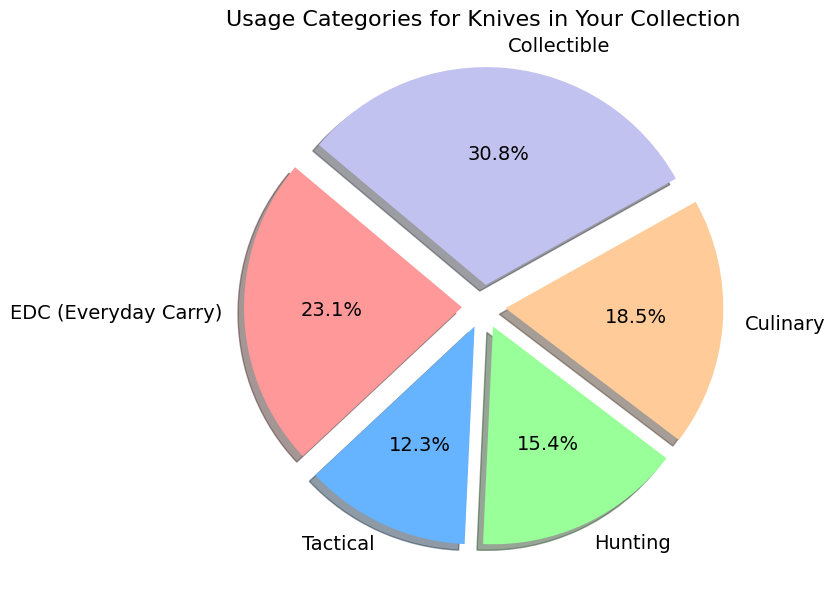What is the most common usage category for knives in your collection? The pie chart shows the proportions of different knife usage categories. The largest section of the pie chart, labeled with the highest percentage, represents the most common category.
Answer: Collectible What percentage of your knife collection is used for Culinary purposes? The percentage for each category is directly labeled on the pie chart. Look for the segment labeled "Culinary".
Answer: 24.0% Which category has more knives: Tactical or Hunting? Compare the respective sections of the pie chart labeled "Tactical" and "Hunting". The size and percentage indicate the quantity, with a higher percentage indicating more knives.
Answer: Hunting How many more knives are there in the Collectible category compared to the EDC category? The pie chart gives the number of knives in each category. Subtract the count for EDC from the count for Collectible: \( 20 - 15 = 5 \).
Answer: 5 What is the combined percentage of knives in EDC and Tactical categories? Add the percentages of both categories from the pie chart. EDC is 30% and Tactical is 16%. So, \( 30\% + 16\% = 46\% \).
Answer: 46% How does the size of the Culinary category compare visually to the Tactical category? Observe the relative sizes of the pie chart sections for Culinary and Tactical. The Culinary section should appear larger than the Tactical section.
Answer: Culinary is larger If you were to add 5 more knives to the Hunting category, what would the new percentage roughly be? The current total number of knives is 65. Adding 5 knives to Hunting makes it 15 knives: \( (10 + 5)/70 \times 100\% \approx 21.4\% \).
Answer: 21.4% Which color section on the pie chart corresponds to the largest category? Identify the section with the highest percentage, which is Collectible, and note its color.
Answer: Light purple (or equivalent description based on actual colors) 